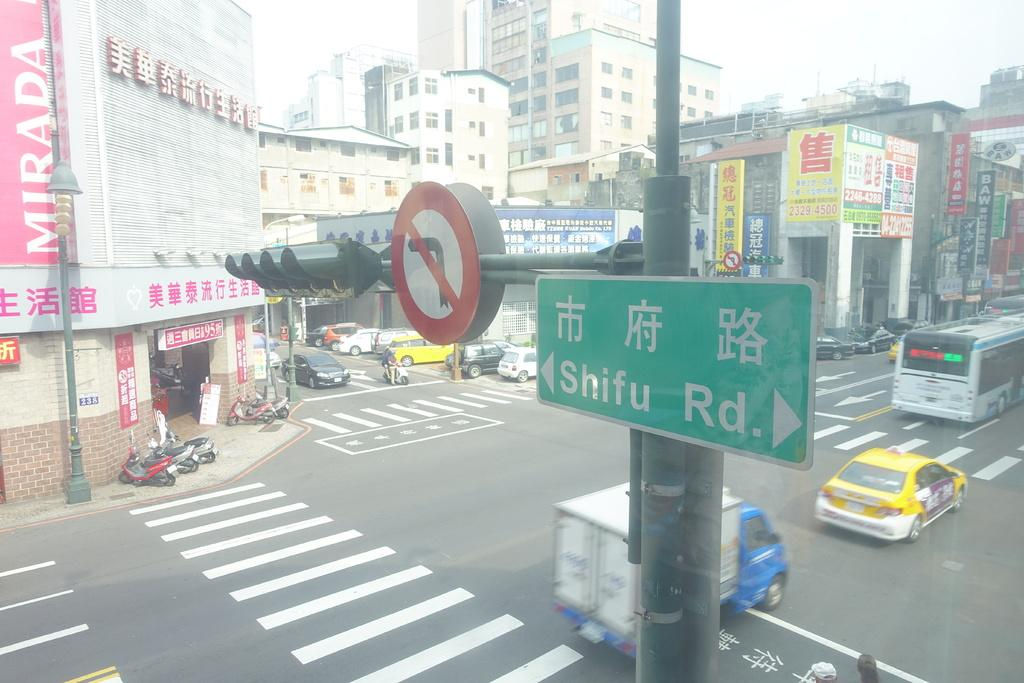<image>
Write a terse but informative summary of the picture. A sign pointing to Shifu Rd is at the top of a busy intersection 